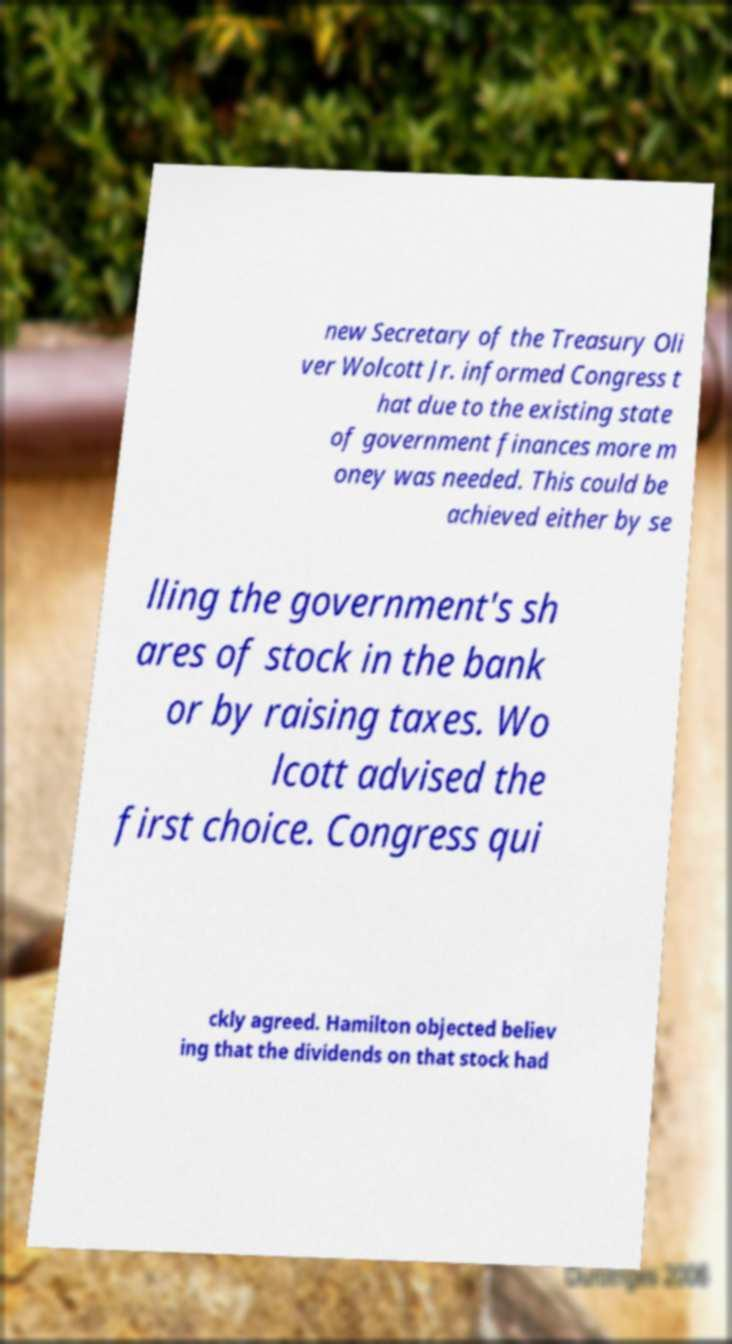Can you accurately transcribe the text from the provided image for me? new Secretary of the Treasury Oli ver Wolcott Jr. informed Congress t hat due to the existing state of government finances more m oney was needed. This could be achieved either by se lling the government's sh ares of stock in the bank or by raising taxes. Wo lcott advised the first choice. Congress qui ckly agreed. Hamilton objected believ ing that the dividends on that stock had 